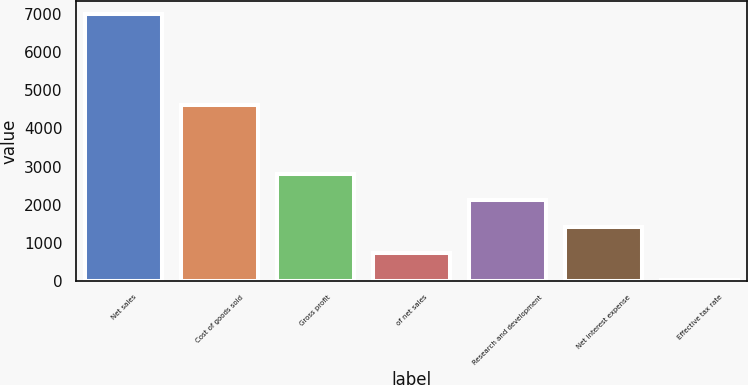Convert chart. <chart><loc_0><loc_0><loc_500><loc_500><bar_chart><fcel>Net sales<fcel>Cost of goods sold<fcel>Gross profit<fcel>of net sales<fcel>Research and development<fcel>Net interest expense<fcel>Effective tax rate<nl><fcel>6999.7<fcel>4629.6<fcel>2815.18<fcel>722.92<fcel>2117.76<fcel>1420.34<fcel>25.5<nl></chart> 